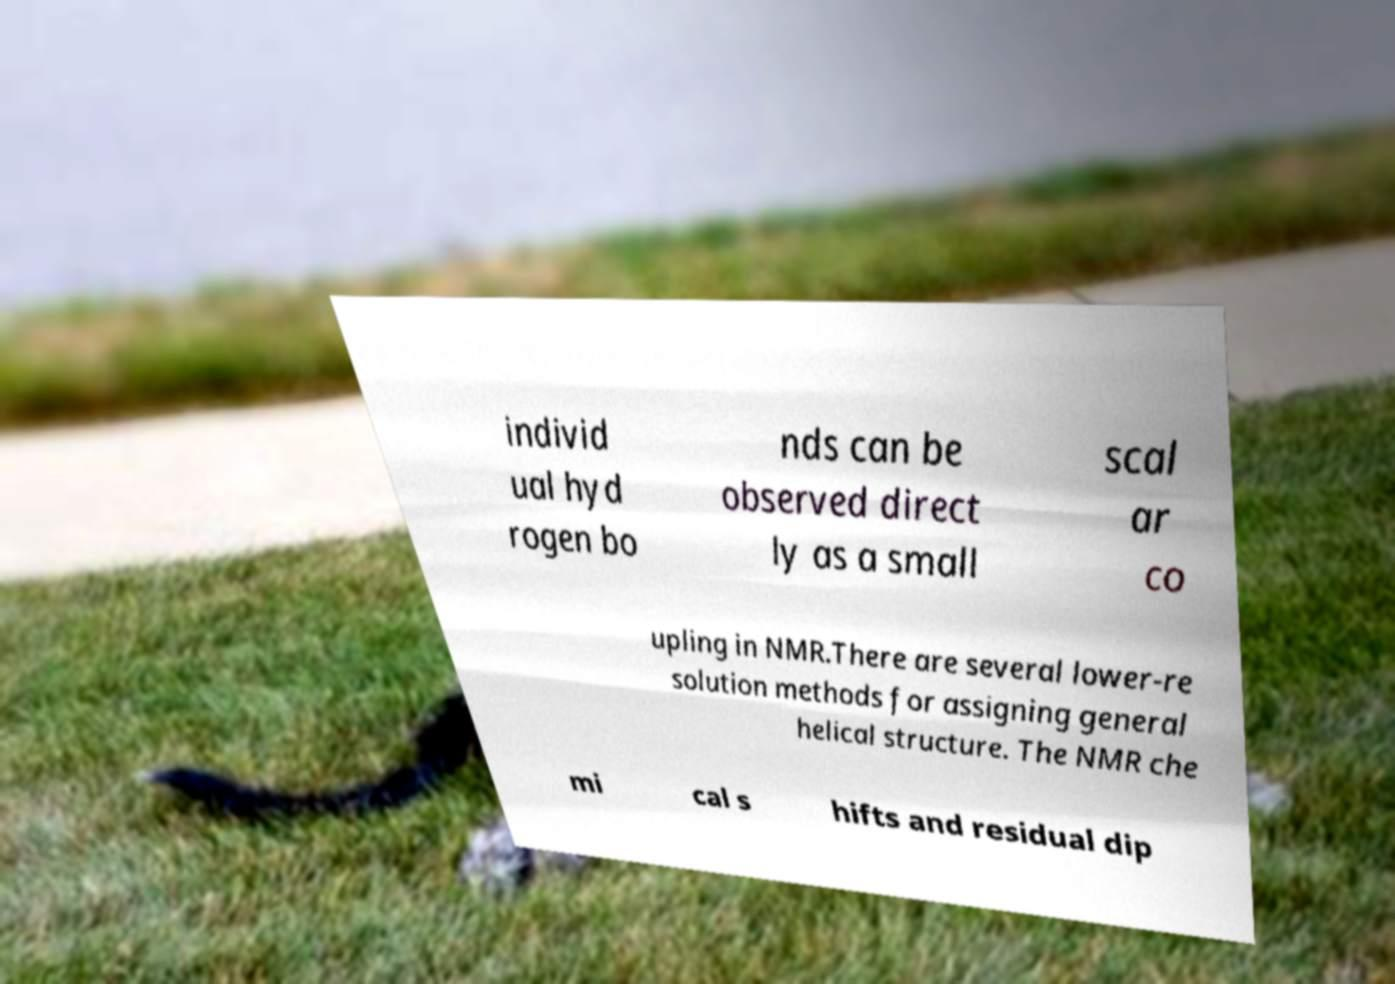I need the written content from this picture converted into text. Can you do that? individ ual hyd rogen bo nds can be observed direct ly as a small scal ar co upling in NMR.There are several lower-re solution methods for assigning general helical structure. The NMR che mi cal s hifts and residual dip 